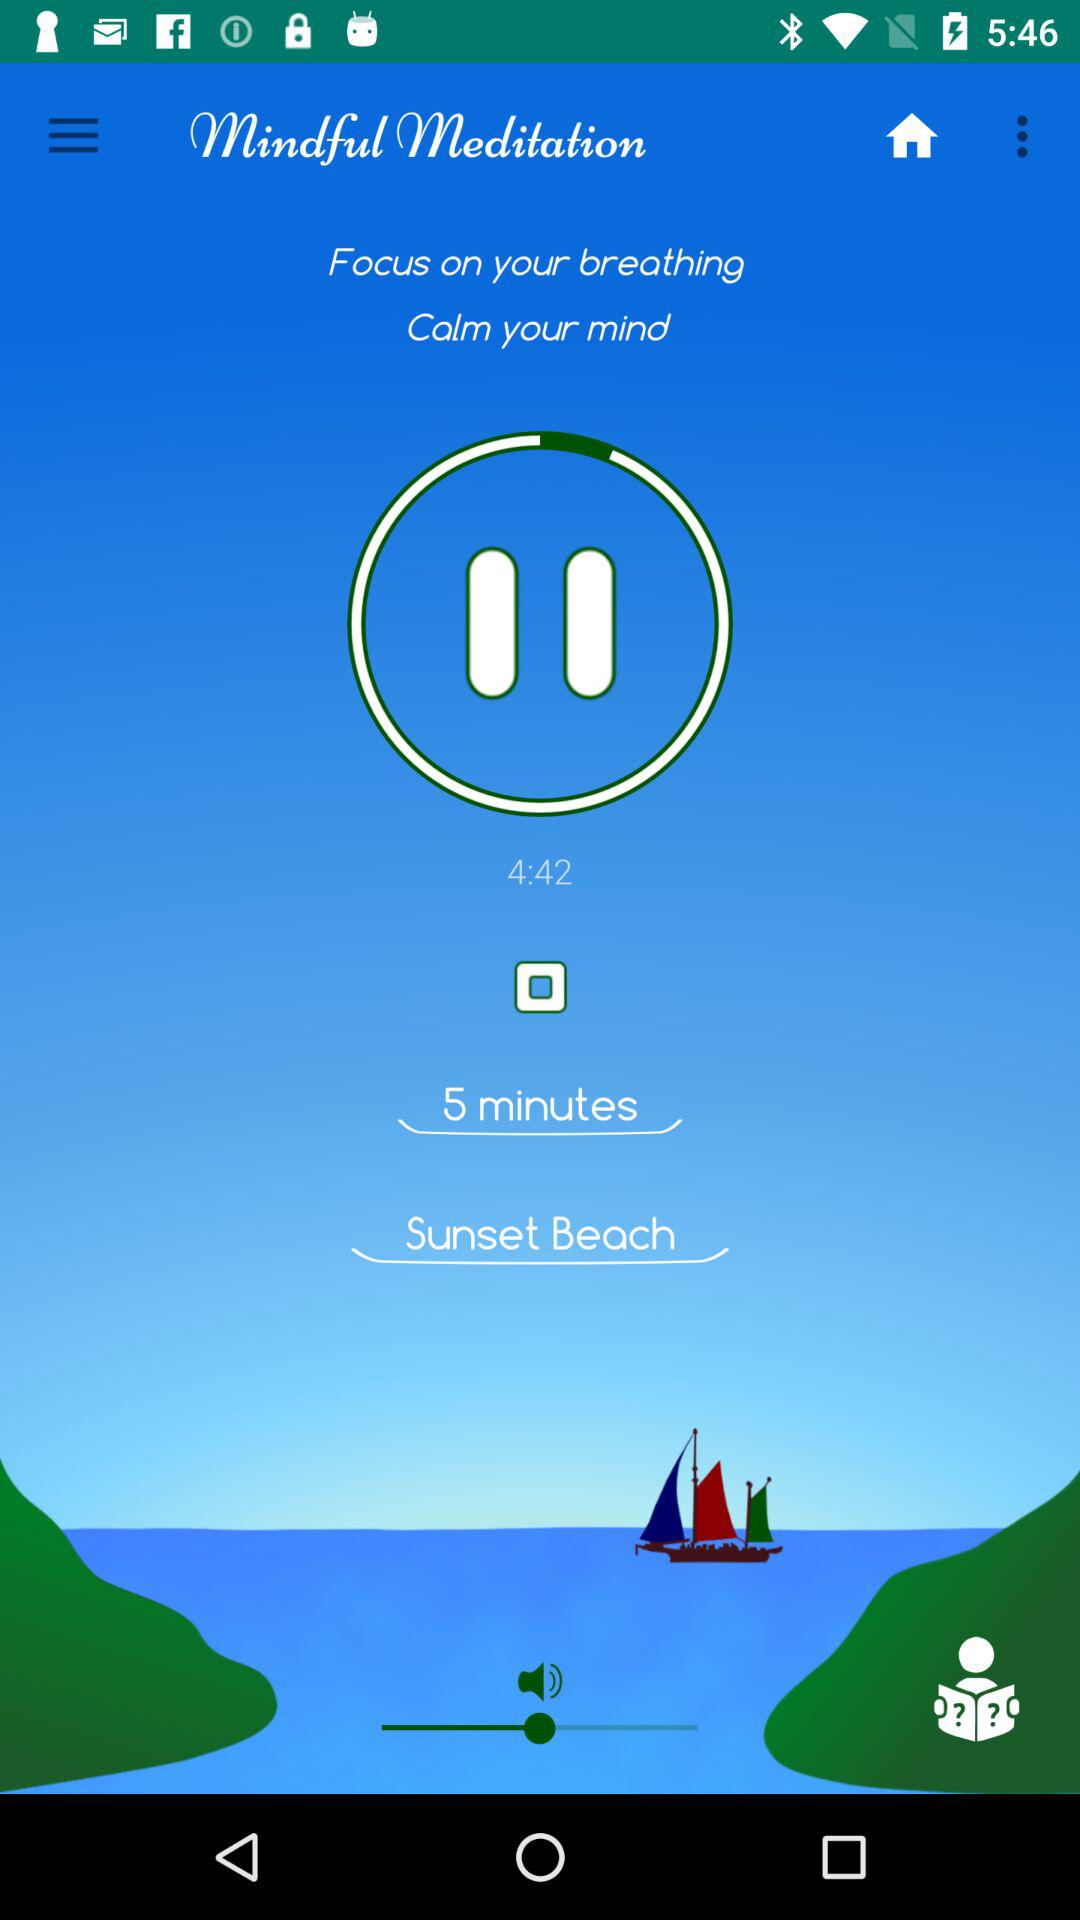What is the name of the selected theme? The name of the selected theme is "Sunset Beach". 